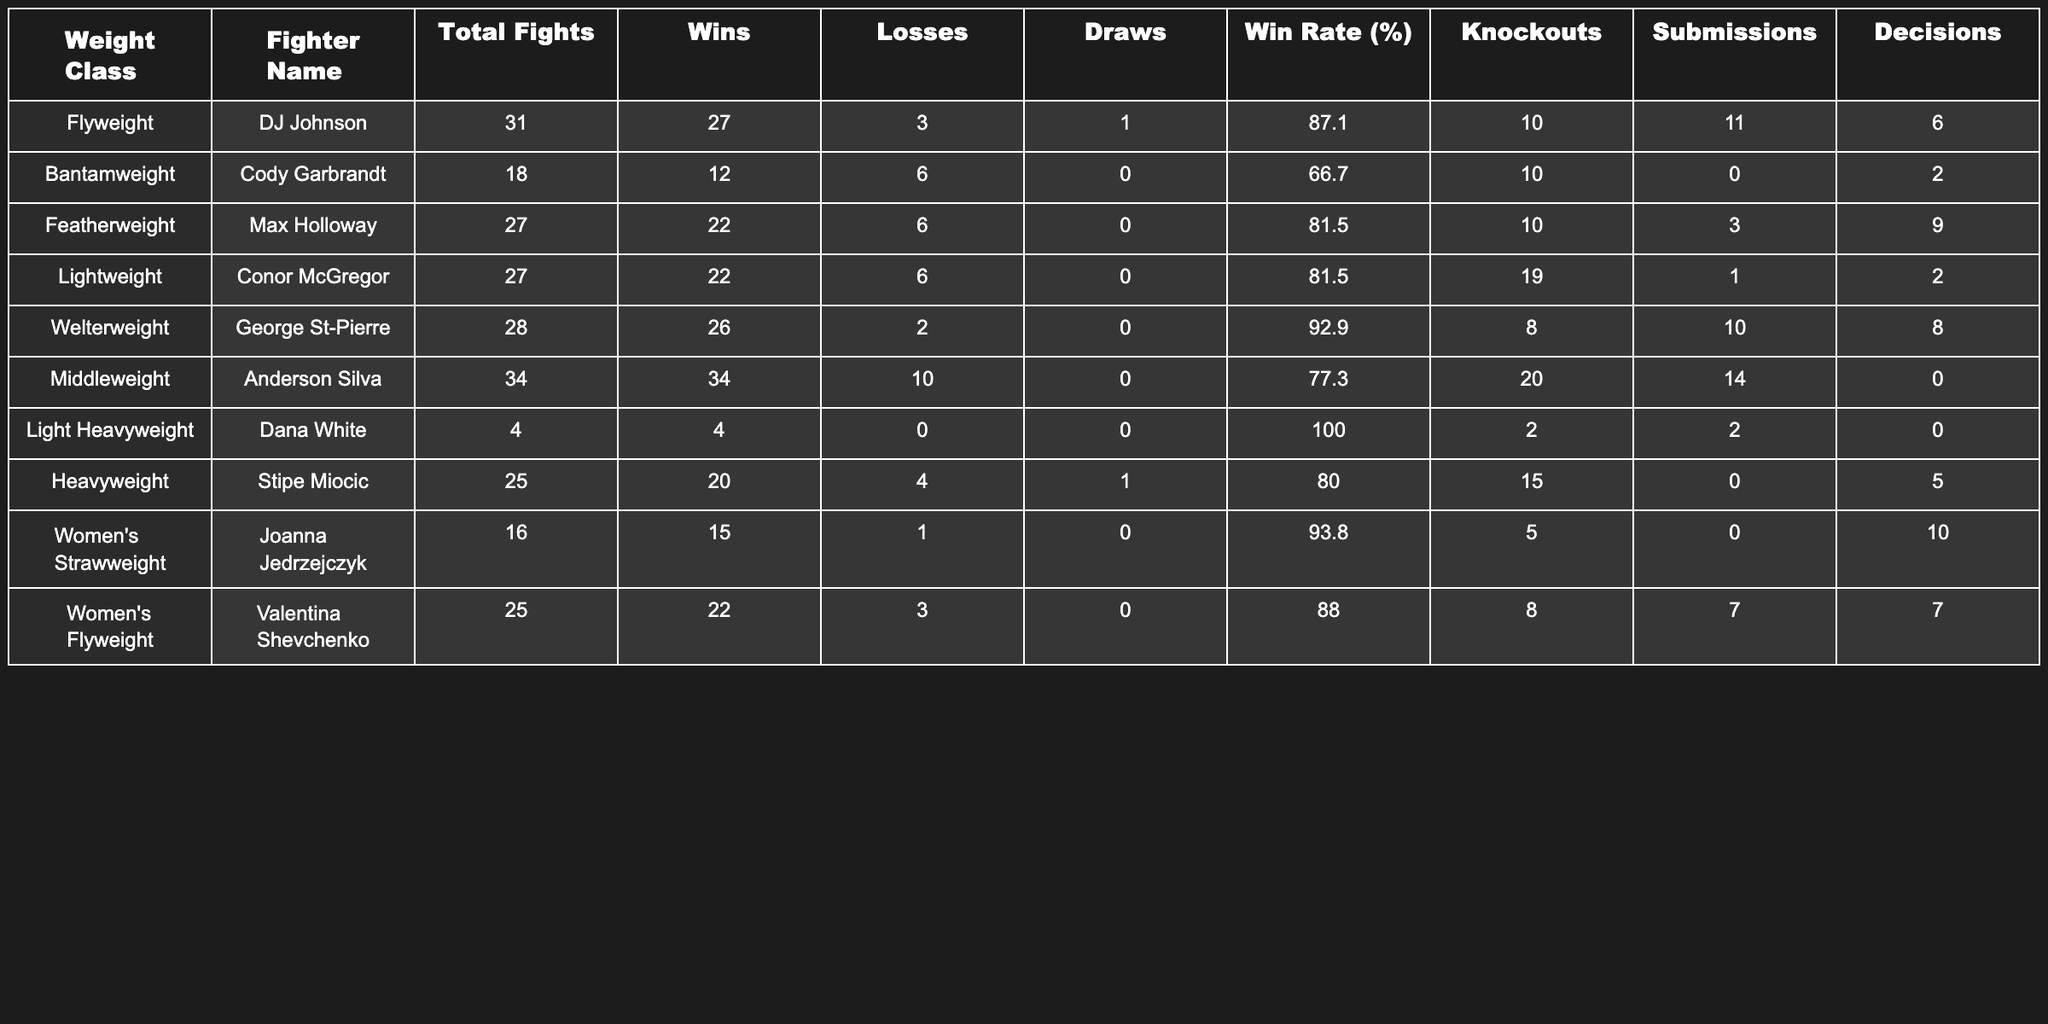What is the win rate of George St-Pierre? The win rate percentage for George St-Pierre is listed directly in the table as 92.9%.
Answer: 92.9% Which fighter has the highest number of total fights? By reviewing the total fights column, Anderson Silva has the highest number of total fights at 34.
Answer: 34 What is the total number of wins for Joanna Jedrzejczyk? The table shows Joanna Jedrzejczyk with a total of 15 wins listed in the wins column.
Answer: 15 Which weight class does DJ Johnson belong to? From the table, DJ Johnson is listed under the Flyweight class.
Answer: Flyweight How many more knockouts does Conor McGregor have compared to Max Holloway? Conor McGregor has 19 knockouts while Max Holloway has 10. The difference is 19 - 10 = 9.
Answer: 9 What is the average win rate of the fighters listed in the Featherweight and Lightweight classes? Max Holloway's win rate is 81.5% and Conor McGregor's win rate is also 81.5%. To find the average, (81.5 + 81.5) / 2 = 81.5%.
Answer: 81.5% Did Dana White lose any fights? Checking the losses column, Dana White has 0 losses, which indicates he has not lost any fights.
Answer: Yes Which fighter has the most submissions in their fight record? The table shows that Anderson Silva has the most submissions with a total of 14 submissions.
Answer: 14 What percentage of Max Holloway's wins came from knockouts? Max Holloway has 22 wins and 10 of those are knockouts. So, (10 / 22) * 100 = 45.45%, which rounds to 45.5%.
Answer: 45.5% Which fighter has the least number of total fights and what class are they in? Dana White has the least total fights at 4, and he is in the Light Heavyweight class.
Answer: Light Heavyweight, 4 fights 